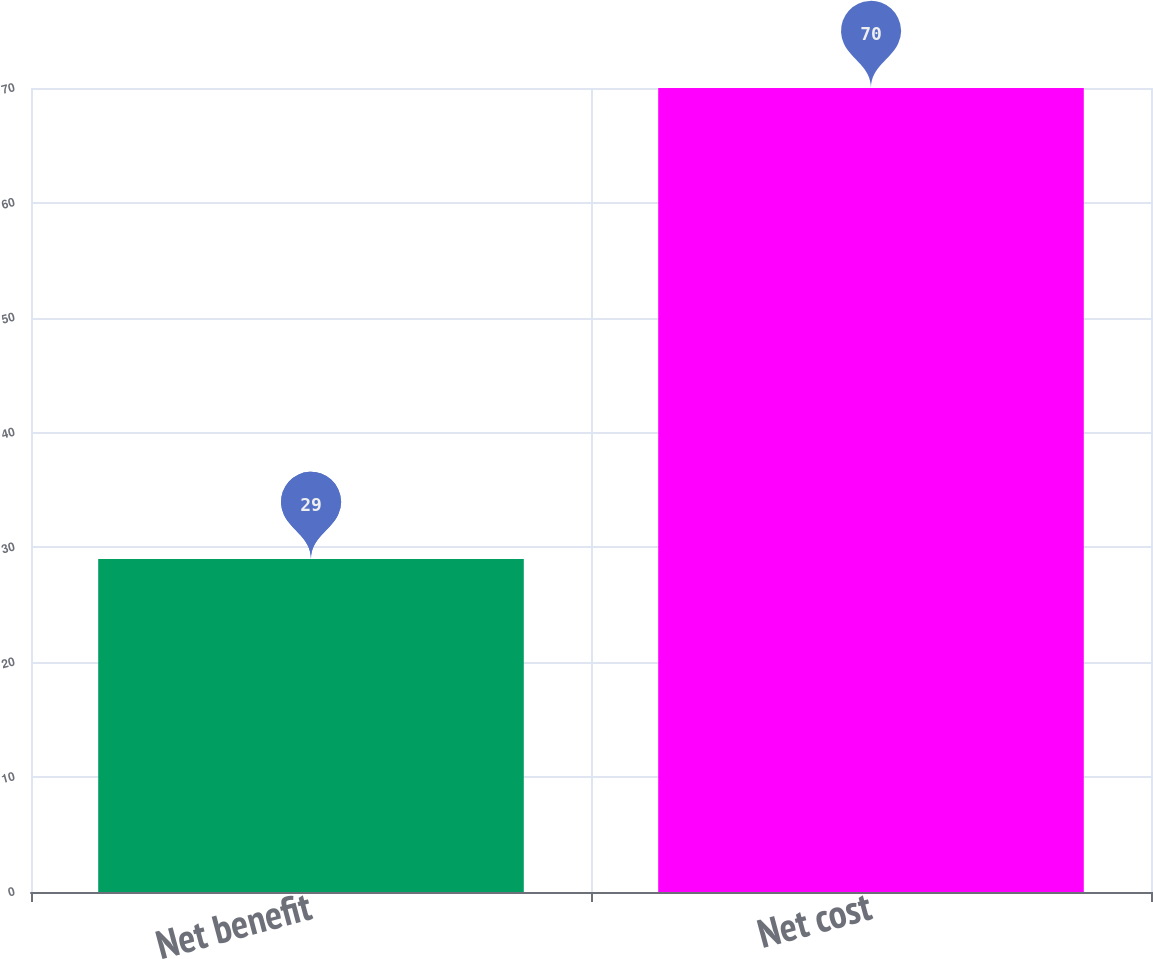Convert chart to OTSL. <chart><loc_0><loc_0><loc_500><loc_500><bar_chart><fcel>Net benefit<fcel>Net cost<nl><fcel>29<fcel>70<nl></chart> 